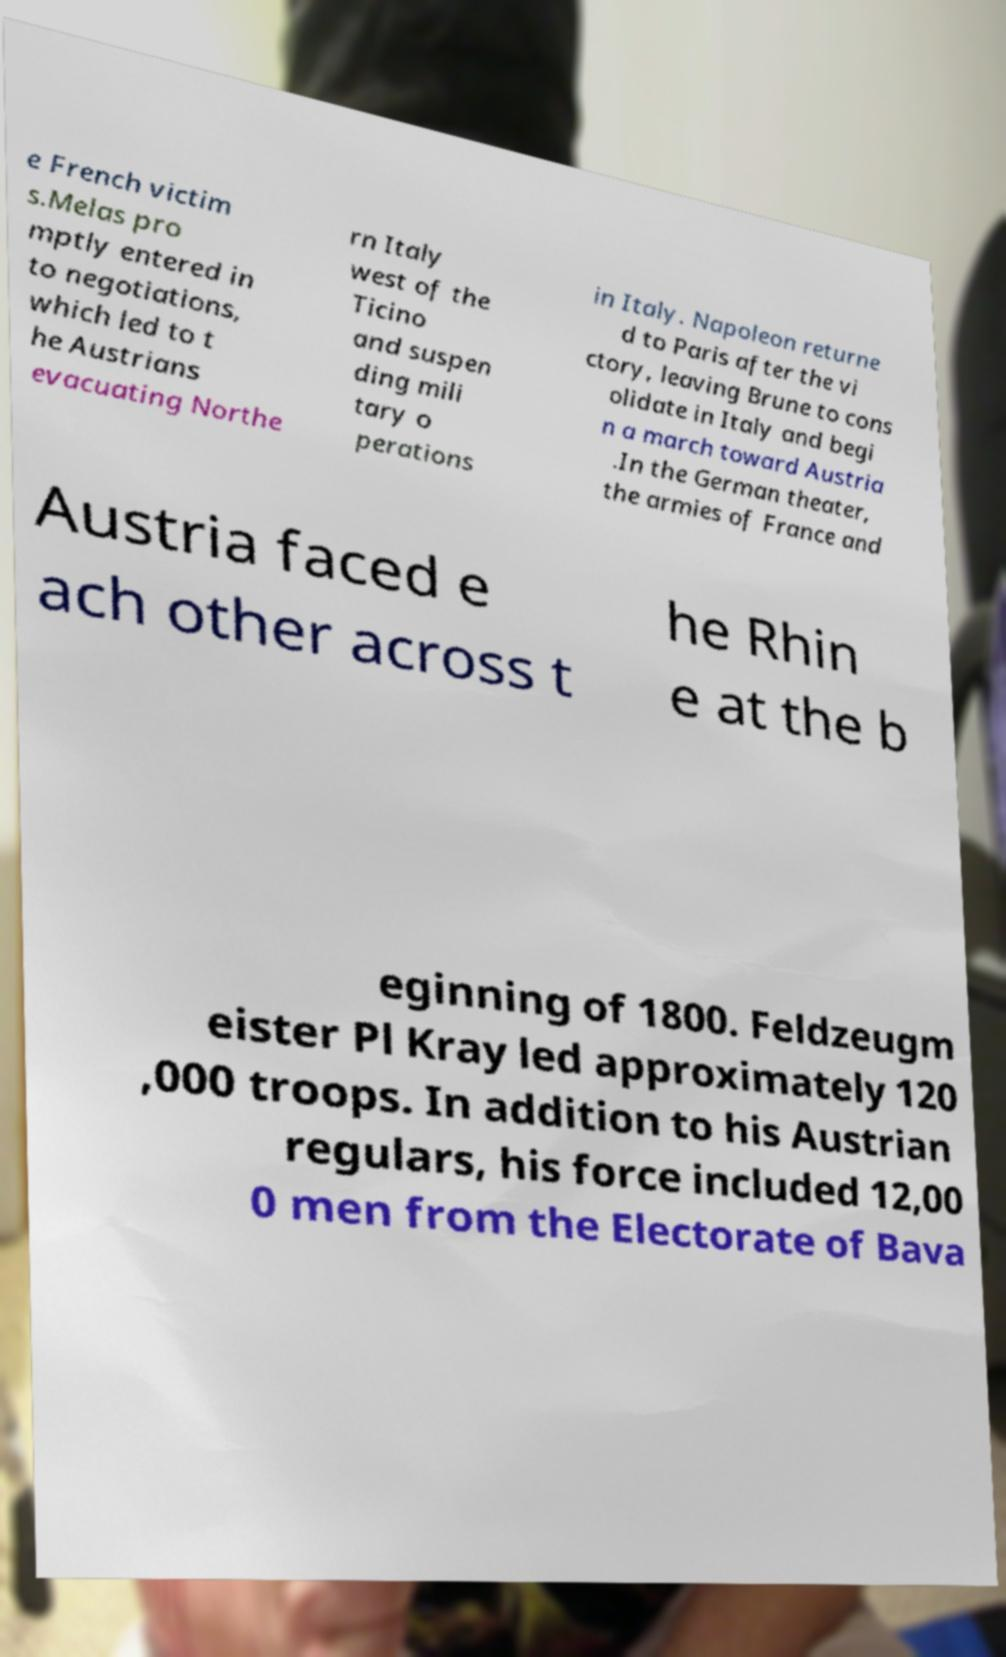There's text embedded in this image that I need extracted. Can you transcribe it verbatim? e French victim s.Melas pro mptly entered in to negotiations, which led to t he Austrians evacuating Northe rn Italy west of the Ticino and suspen ding mili tary o perations in Italy. Napoleon returne d to Paris after the vi ctory, leaving Brune to cons olidate in Italy and begi n a march toward Austria .In the German theater, the armies of France and Austria faced e ach other across t he Rhin e at the b eginning of 1800. Feldzeugm eister Pl Kray led approximately 120 ,000 troops. In addition to his Austrian regulars, his force included 12,00 0 men from the Electorate of Bava 